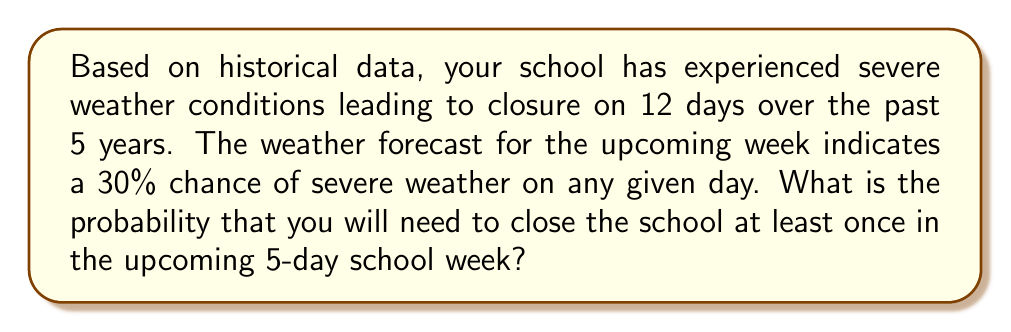Can you solve this math problem? Let's approach this step-by-step:

1. First, we need to calculate the probability of a school closure on any given day based on historical data:
   $$P(\text{closure per day}) = \frac{12 \text{ days}}{5 \text{ years} \times 180 \text{ school days per year}} = \frac{12}{900} = \frac{1}{75} \approx 0.0133$$

2. However, we're given a weather forecast that indicates a 30% chance of severe weather. We should use this more current information:
   $$P(\text{severe weather}) = 0.30$$

3. To find the probability of at least one closure in 5 days, it's easier to calculate the probability of no closures and then subtract from 1:
   $$P(\text{at least one closure}) = 1 - P(\text{no closures})$$

4. The probability of no closure on a single day is:
   $$P(\text{no closure}) = 1 - 0.30 = 0.70$$

5. For no closures in 5 days, we need this to happen 5 times in a row:
   $$P(\text{no closures in 5 days}) = (0.70)^5 \approx 0.1681$$

6. Therefore, the probability of at least one closure in 5 days is:
   $$P(\text{at least one closure in 5 days}) = 1 - 0.1681 = 0.8319$$

7. Converting to a percentage:
   $$0.8319 \times 100\% = 83.19\%$$
Answer: 83.19% 